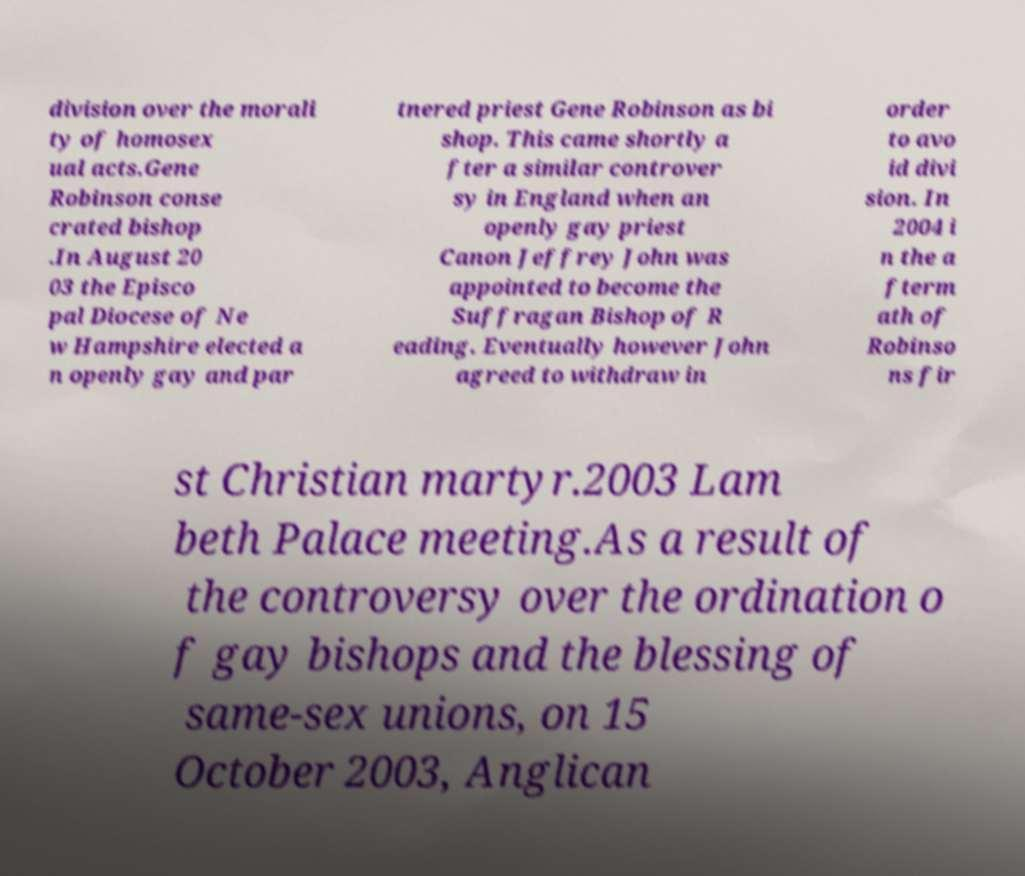What messages or text are displayed in this image? I need them in a readable, typed format. division over the morali ty of homosex ual acts.Gene Robinson conse crated bishop .In August 20 03 the Episco pal Diocese of Ne w Hampshire elected a n openly gay and par tnered priest Gene Robinson as bi shop. This came shortly a fter a similar controver sy in England when an openly gay priest Canon Jeffrey John was appointed to become the Suffragan Bishop of R eading. Eventually however John agreed to withdraw in order to avo id divi sion. In 2004 i n the a fterm ath of Robinso ns fir st Christian martyr.2003 Lam beth Palace meeting.As a result of the controversy over the ordination o f gay bishops and the blessing of same-sex unions, on 15 October 2003, Anglican 